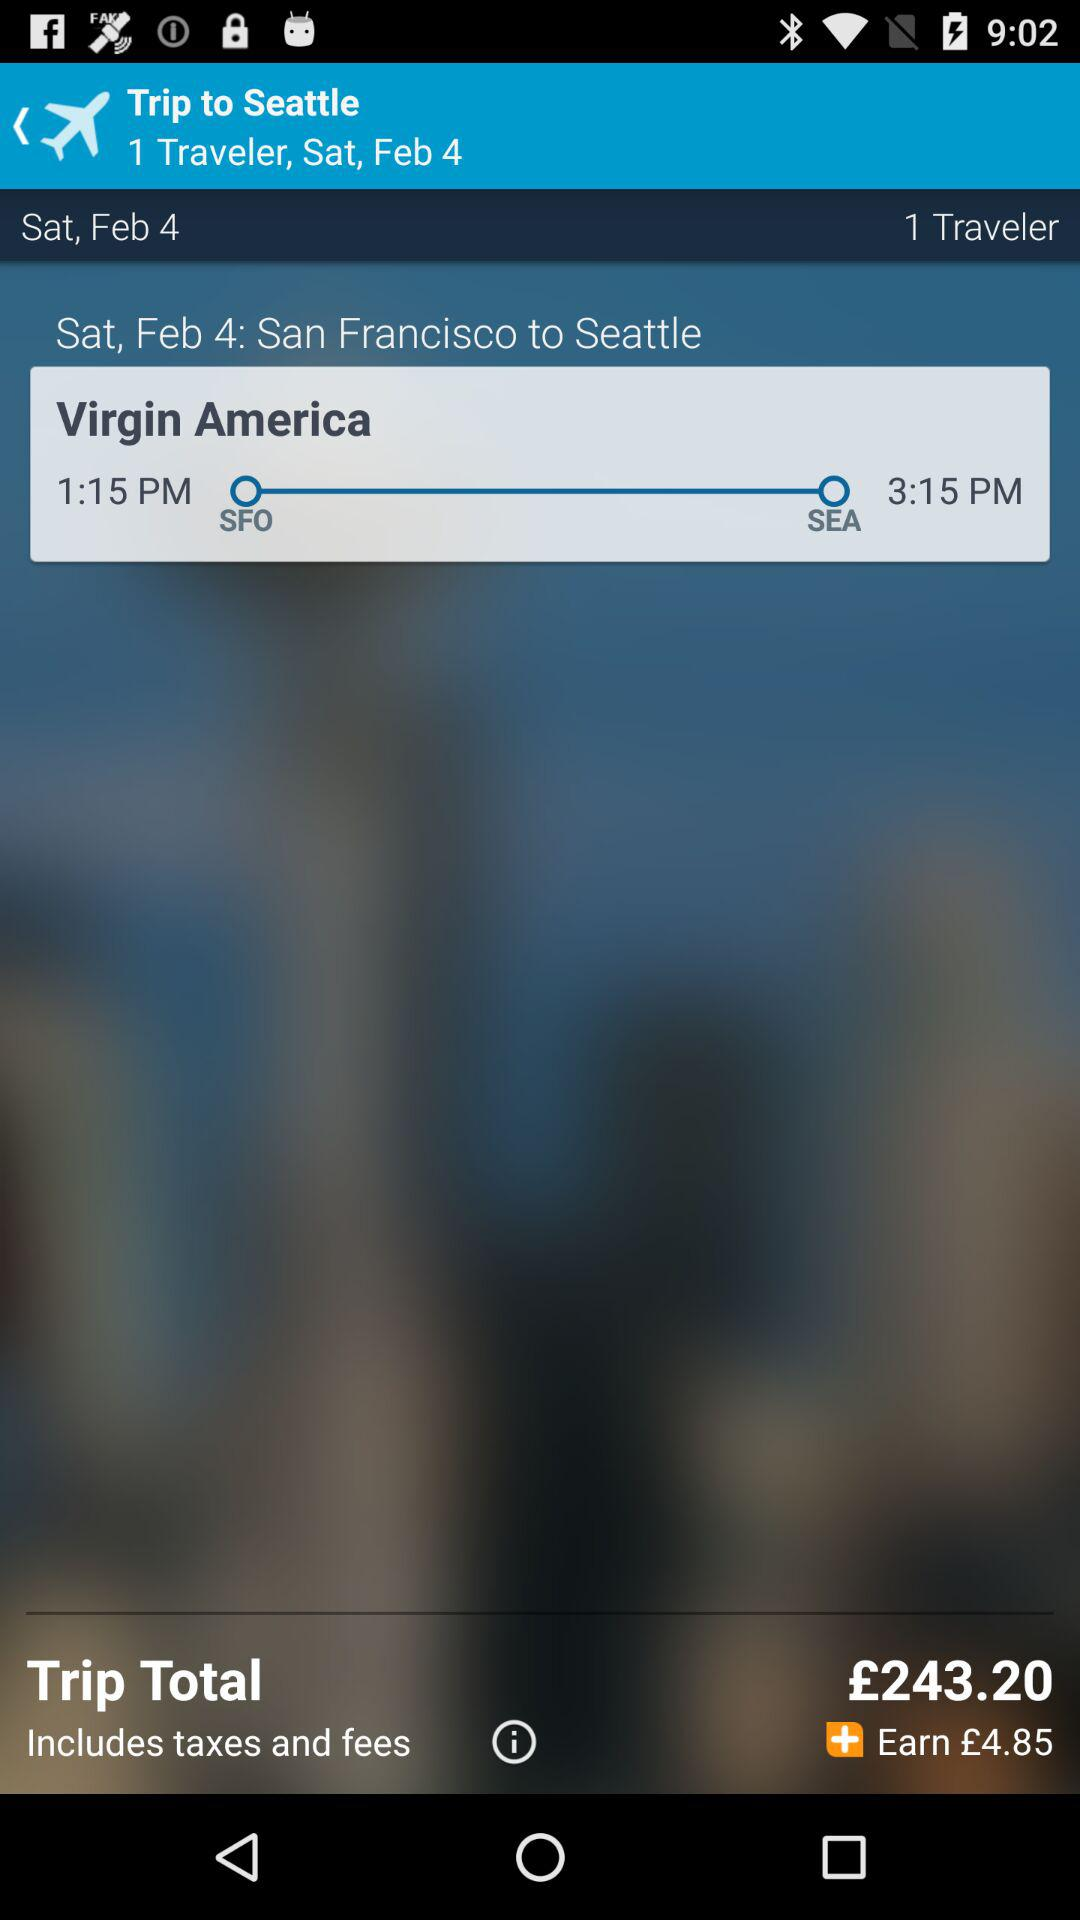What is the arrival time? The arrival time is 3:15 p.m. 